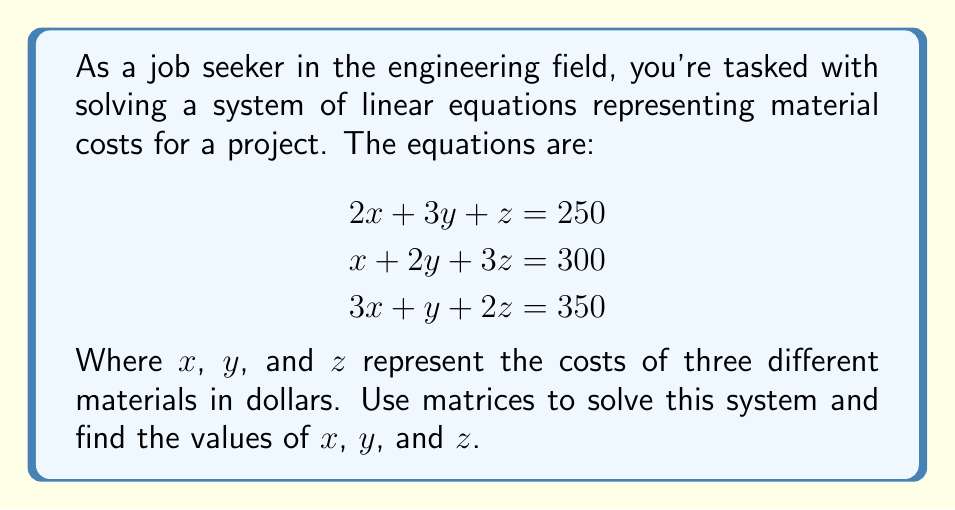Show me your answer to this math problem. Let's solve this step-by-step using matrices:

1) First, we'll set up the augmented matrix:

   $$\begin{bmatrix}
   2 & 3 & 1 & | & 250 \\
   1 & 2 & 3 & | & 300 \\
   3 & 1 & 2 & | & 350
   \end{bmatrix}$$

2) Now, we'll use Gaussian elimination to transform this into row echelon form:

   - Multiply row 1 by -1/2 and add to row 2:
   $$\begin{bmatrix}
   2 & 3 & 1 & | & 250 \\
   0 & 0.5 & 2.5 & | & 175 \\
   3 & 1 & 2 & | & 350
   \end{bmatrix}$$

   - Multiply row 1 by -3/2 and add to row 3:
   $$\begin{bmatrix}
   2 & 3 & 1 & | & 250 \\
   0 & 0.5 & 2.5 & | & 175 \\
   0 & -3.5 & 0.5 & | & -25
   \end{bmatrix}$$

3) Continue to reduce:

   - Multiply row 2 by 2:
   $$\begin{bmatrix}
   2 & 3 & 1 & | & 250 \\
   0 & 1 & 5 & | & 350 \\
   0 & -3.5 & 0.5 & | & -25
   \end{bmatrix}$$

   - Multiply row 2 by 3.5 and add to row 3:
   $$\begin{bmatrix}
   2 & 3 & 1 & | & 250 \\
   0 & 1 & 5 & | & 350 \\
   0 & 0 & 18 & | & 1200
   \end{bmatrix}$$

4) Now we have the system in row echelon form. We can solve by back-substitution:

   From row 3: $18z = 1200$, so $z = 66.67$

   From row 2: $y + 5z = 350$, so $y + 5(66.67) = 350$
               $y = 350 - 333.35 = 16.65$

   From row 1: $2x + 3y + z = 250$, so $2x + 3(16.65) + 66.67 = 250$
               $2x = 250 - 49.95 - 66.67 = 133.38$
               $x = 66.69$

5) Rounding to two decimal places:
   $x = 66.69$, $y = 16.65$, $z = 66.67$
Answer: $x = 66.69$, $y = 16.65$, $z = 66.67$ 